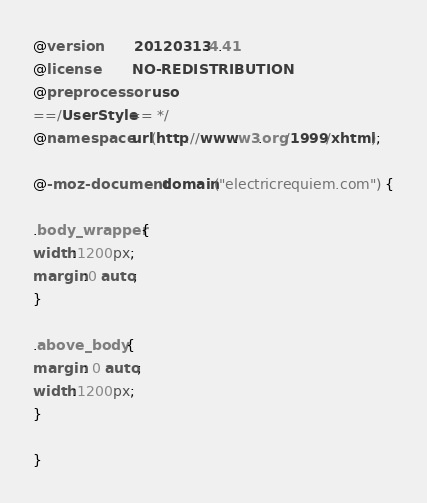Convert code to text. <code><loc_0><loc_0><loc_500><loc_500><_CSS_>@version        20120313.4.41
@license        NO-REDISTRIBUTION
@preprocessor   uso
==/UserStyle== */
@namespace url(http://www.w3.org/1999/xhtml);

@-moz-document domain("electricrequiem.com") {

.body_wrapper {
width:1200px;
margin:0 auto;
}

.above_body {
margin: 0 auto;
width:1200px;
}

}
</code> 